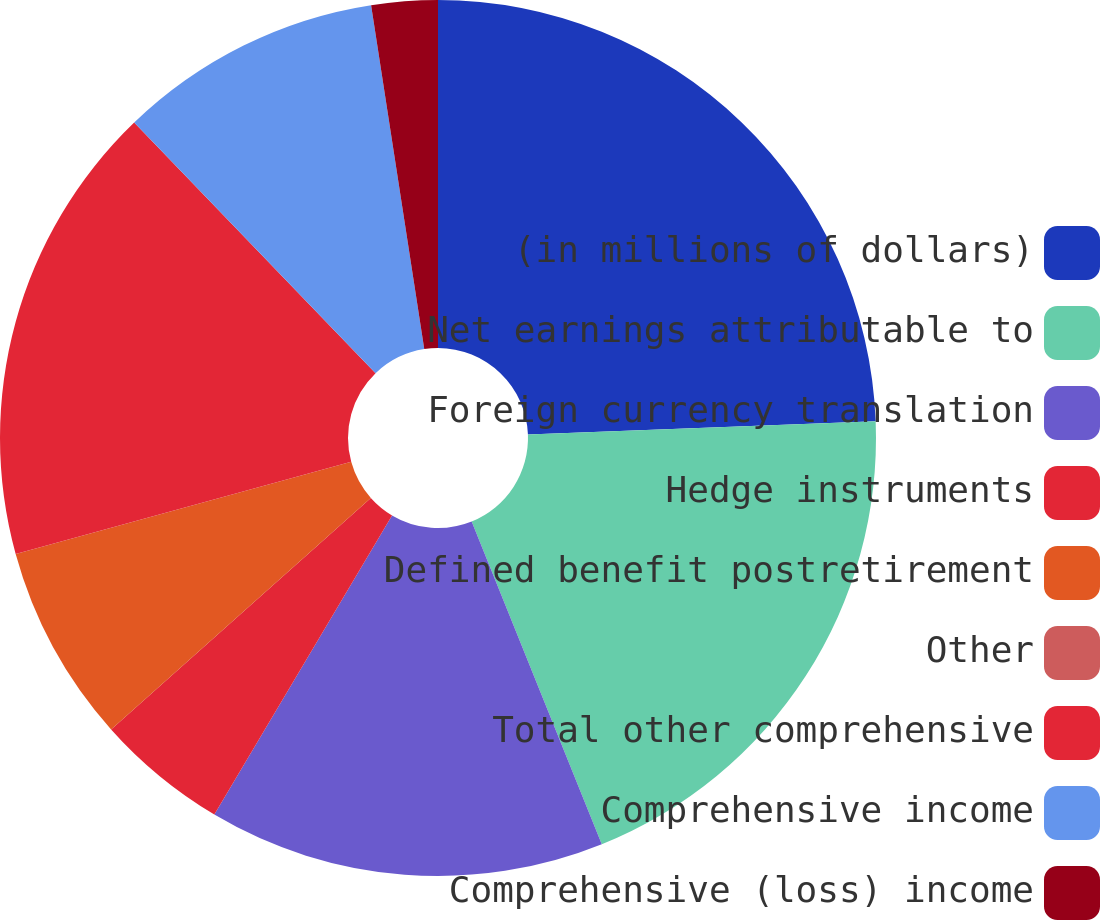Convert chart to OTSL. <chart><loc_0><loc_0><loc_500><loc_500><pie_chart><fcel>(in millions of dollars)<fcel>Net earnings attributable to<fcel>Foreign currency translation<fcel>Hedge instruments<fcel>Defined benefit postretirement<fcel>Other<fcel>Total other comprehensive<fcel>Comprehensive income<fcel>Comprehensive (loss) income<nl><fcel>24.39%<fcel>19.51%<fcel>14.63%<fcel>4.88%<fcel>7.32%<fcel>0.0%<fcel>17.07%<fcel>9.76%<fcel>2.44%<nl></chart> 